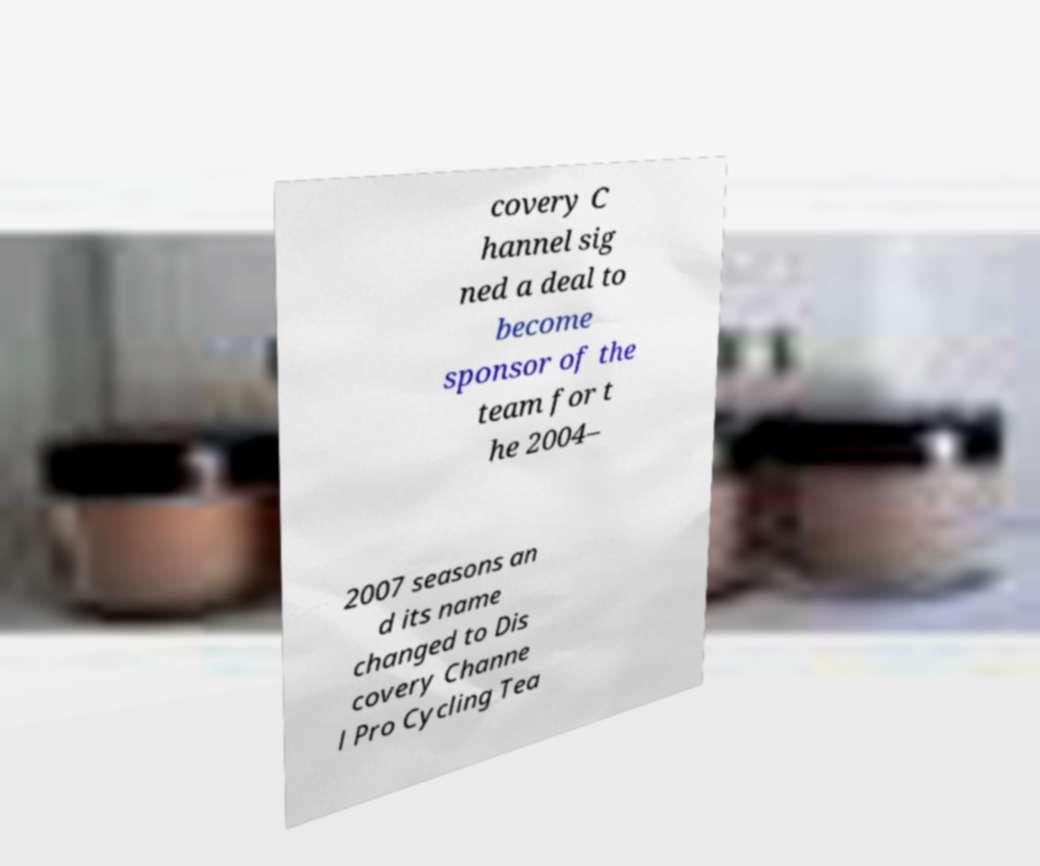For documentation purposes, I need the text within this image transcribed. Could you provide that? covery C hannel sig ned a deal to become sponsor of the team for t he 2004– 2007 seasons an d its name changed to Dis covery Channe l Pro Cycling Tea 